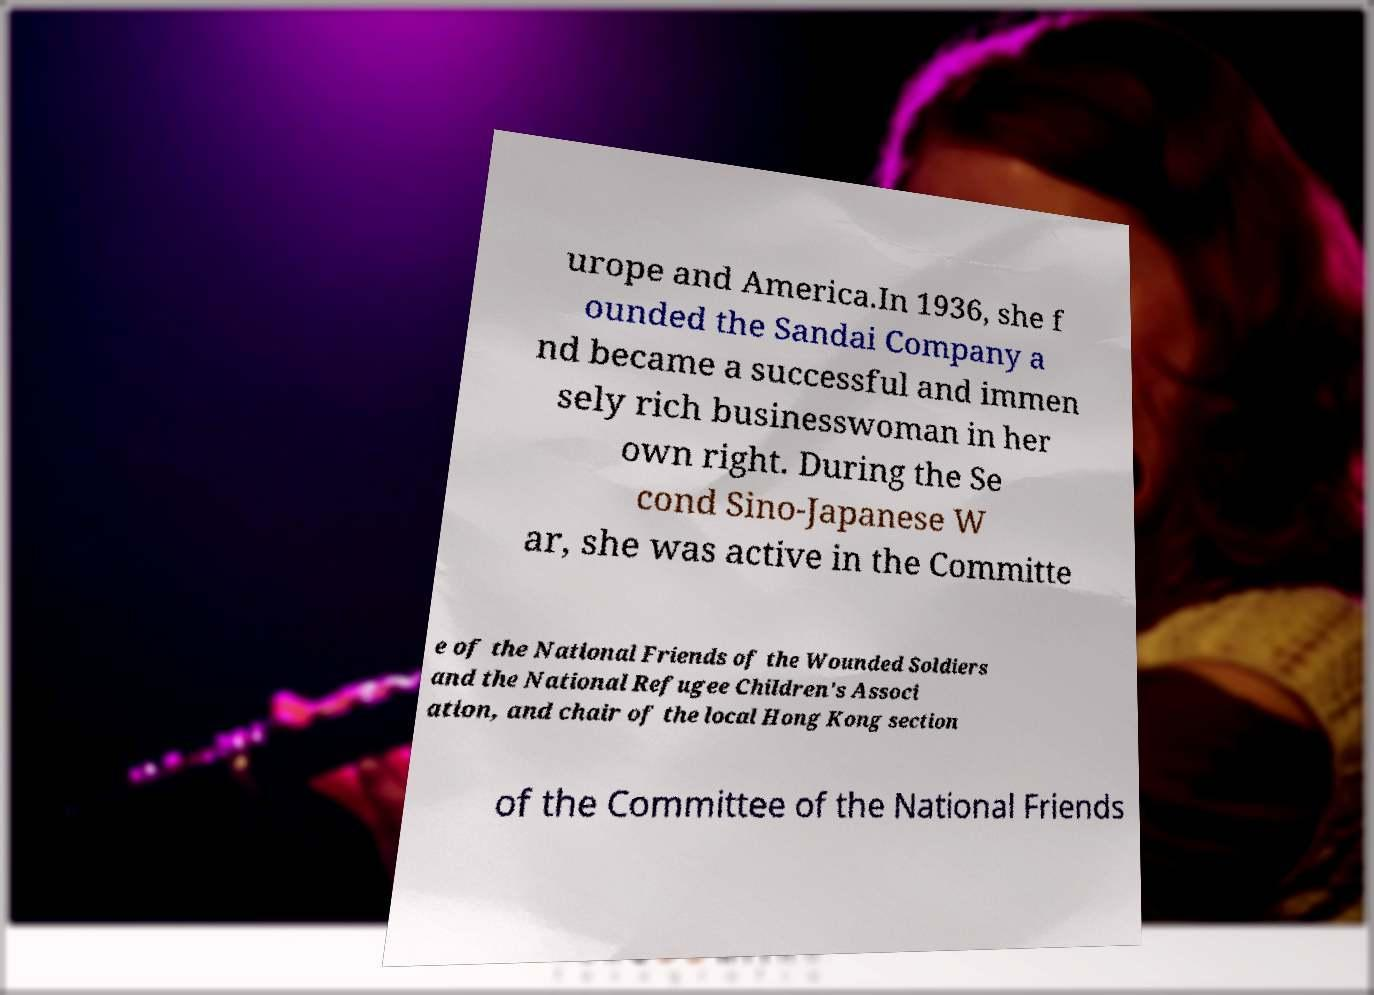Please read and relay the text visible in this image. What does it say? urope and America.In 1936, she f ounded the Sandai Company a nd became a successful and immen sely rich businesswoman in her own right. During the Se cond Sino-Japanese W ar, she was active in the Committe e of the National Friends of the Wounded Soldiers and the National Refugee Children's Associ ation, and chair of the local Hong Kong section of the Committee of the National Friends 